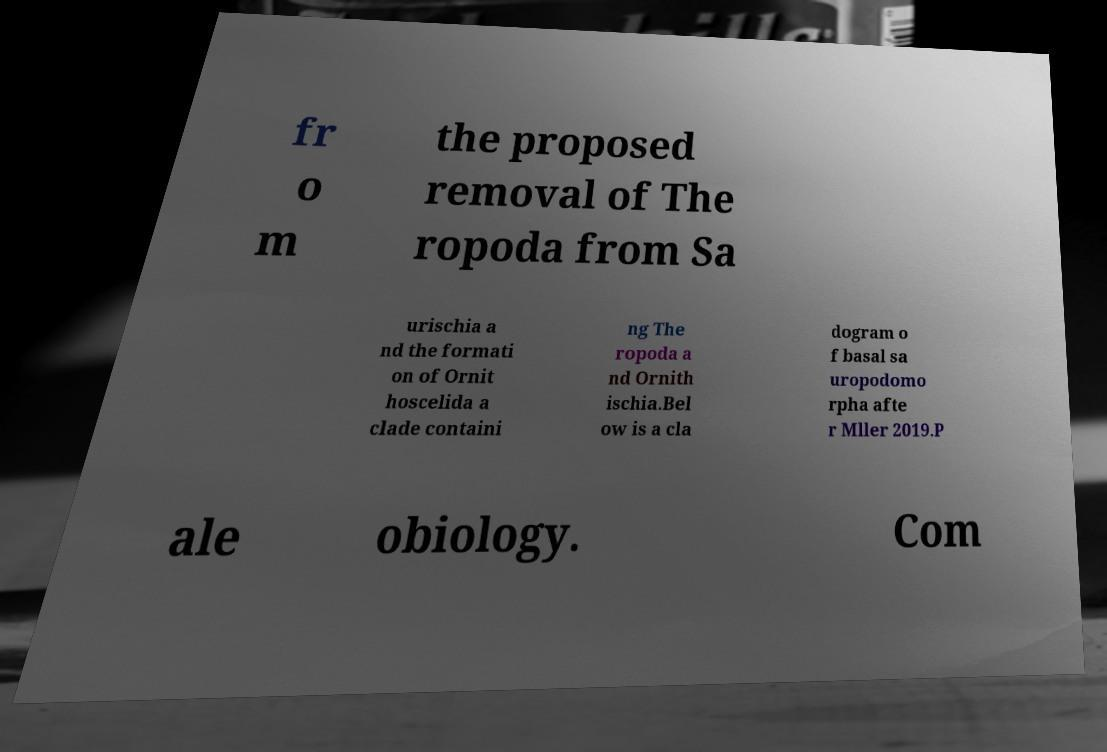Could you extract and type out the text from this image? fr o m the proposed removal of The ropoda from Sa urischia a nd the formati on of Ornit hoscelida a clade containi ng The ropoda a nd Ornith ischia.Bel ow is a cla dogram o f basal sa uropodomo rpha afte r Mller 2019.P ale obiology. Com 